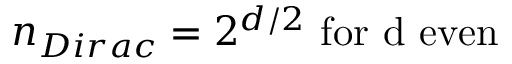<formula> <loc_0><loc_0><loc_500><loc_500>n _ { D i r a c } = 2 ^ { d / 2 } f o r d e v e n</formula> 